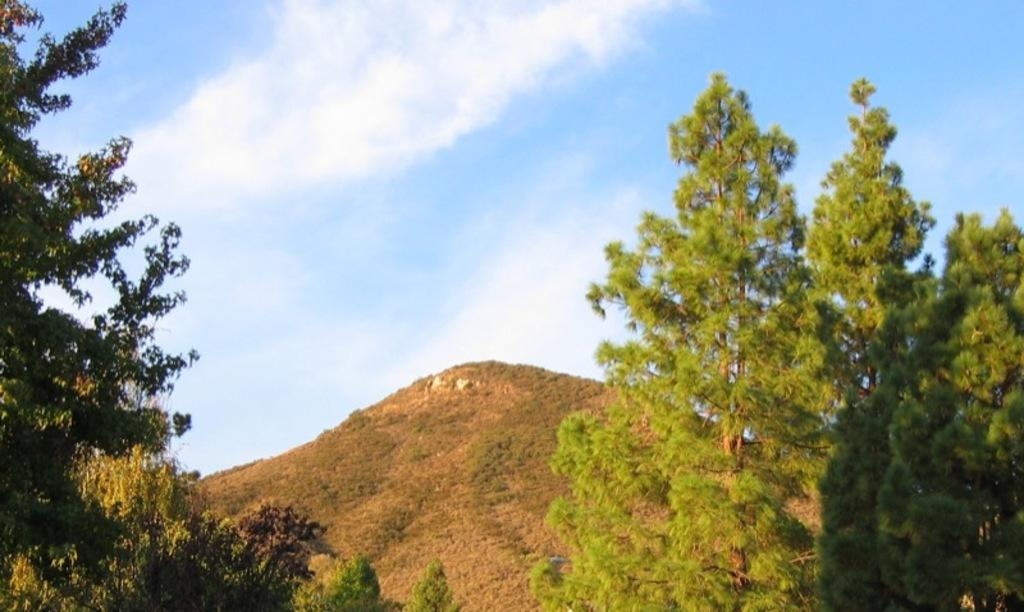What type of natural elements can be seen in the image? There are trees and a mountain in the image. What part of the natural environment is visible in the image? The sky is visible in the image. How many crayons can be seen on the mountain? There are no crayons present in the image. What type of insect can be seen on the leaves of the trees? There are no insects, including ladybugs, visible in the image. 